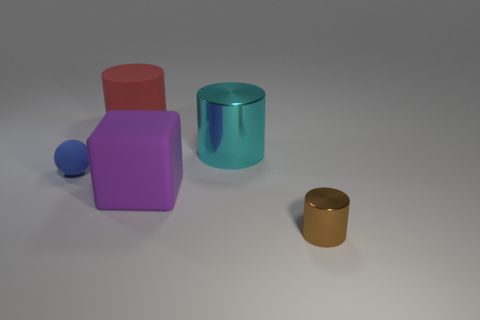What number of things are either cyan cylinders or spheres? 2 